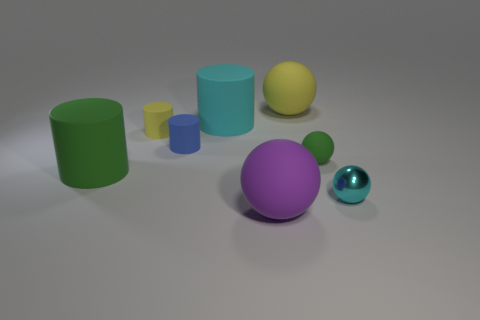The yellow cylinder has what size?
Provide a short and direct response. Small. How many purple matte objects are the same size as the purple matte ball?
Keep it short and to the point. 0. Are there fewer large spheres in front of the green cylinder than purple things on the right side of the small green rubber sphere?
Give a very brief answer. No. What size is the green thing left of the big ball in front of the cyan object that is to the right of the big cyan cylinder?
Offer a terse response. Large. There is a ball that is both in front of the small green rubber object and left of the tiny cyan thing; what is its size?
Offer a very short reply. Large. What is the shape of the tiny object in front of the large matte object left of the tiny blue cylinder?
Your response must be concise. Sphere. Is there anything else that has the same color as the metallic sphere?
Offer a terse response. Yes. There is a cyan object that is behind the small cyan sphere; what is its shape?
Give a very brief answer. Cylinder. There is a big rubber object that is on the right side of the cyan rubber cylinder and behind the metal object; what is its shape?
Your response must be concise. Sphere. What number of blue objects are large rubber spheres or big rubber things?
Make the answer very short. 0. 